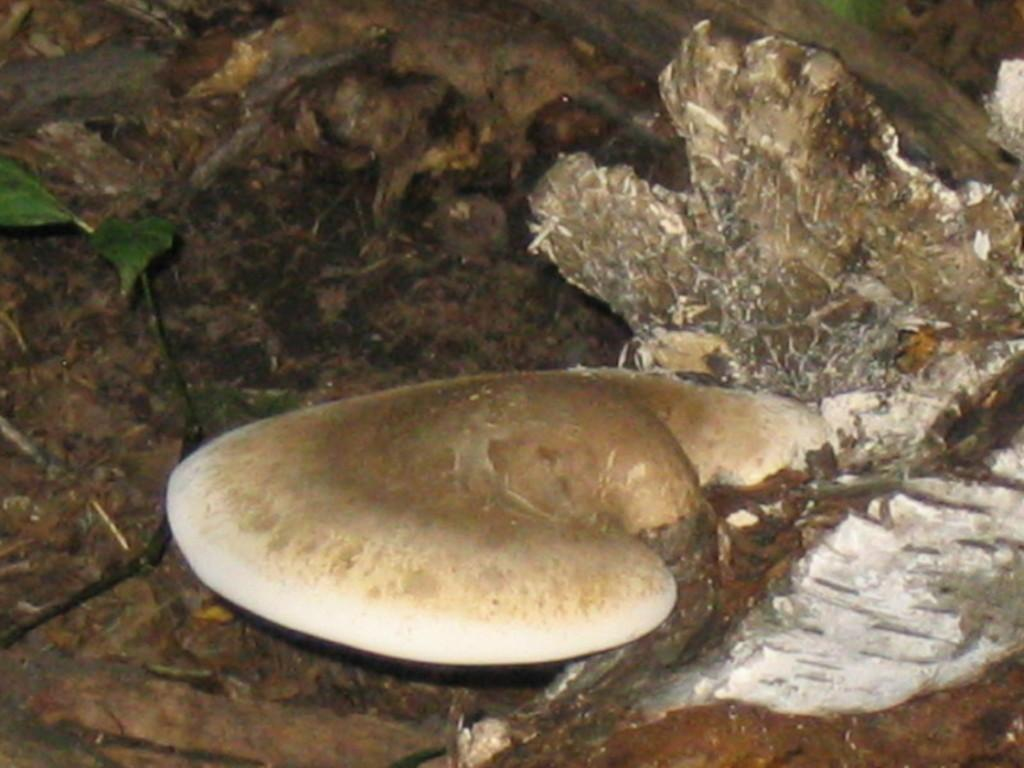What type of fungi can be seen in the image? There is a mushroom in the image. What other type of plant is present in the image? There is a plant in the image. What is the surface on which the mushroom and plant are growing? The ground is visible in the image. What type of decision can be seen in the image? There is no decision present in the image; it features a mushroom, a plant, and the ground. Is there a volcano visible in the image? No, there is no volcano present in the image. 